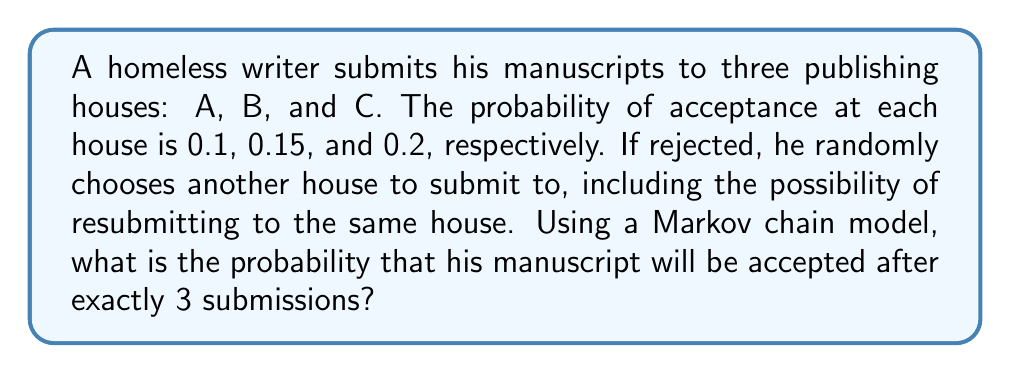Could you help me with this problem? Let's approach this step-by-step using a Markov chain model:

1) First, we need to define our states:
   - State A: Submitted to house A
   - State B: Submitted to house B
   - State C: Submitted to house C
   - State D: Accepted (absorbing state)

2) Now, let's create the transition matrix P:

   $$P = \begin{bmatrix}
   0.3 & 0.3 & 0.3 & 0.1 \\
   0.283̄ & 0.283̄ & 0.283̄ & 0.15 \\
   0.2666̄ & 0.2666̄ & 0.2666̄ & 0.2 \\
   0 & 0 & 0 & 1
   \end{bmatrix}$$

   Where the rows represent the current state and the columns represent the next state.

3) The probability of being accepted after exactly 3 submissions is the sum of the probabilities of:
   - Submitting to A twice, then getting accepted on the third try at A, B, or C
   - Submitting to B twice, then getting accepted on the third try at A, B, or C
   - Submitting to C twice, then getting accepted on the third try at A, B, or C

4) We can calculate this using matrix multiplication:

   $$\begin{bmatrix}
   \frac{1}{3} & \frac{1}{3} & \frac{1}{3} & 0
   \end{bmatrix} \cdot P^2 \cdot \begin{bmatrix}
   0.1 \\ 0.15 \\ 0.2 \\ 1
   \end{bmatrix}$$

5) Calculating $P^2$:

   $$P^2 = \begin{bmatrix}
   0.27 & 0.27 & 0.27 & 0.19 \\
   0.2633̄ & 0.2633̄ & 0.2633̄ & 0.21 \\
   0.2566̄ & 0.2566̄ & 0.2566̄ & 0.23 \\
   0 & 0 & 0 & 1
   \end{bmatrix}$$

6) Performing the final matrix multiplication:

   $$\frac{1}{3}(0.27 \cdot 0.1 + 0.27 \cdot 0.15 + 0.27 \cdot 0.2) +$$
   $$\frac{1}{3}(0.2633̄ \cdot 0.1 + 0.2633̄ \cdot 0.15 + 0.2633̄ \cdot 0.2) +$$
   $$\frac{1}{3}(0.2566̄ \cdot 0.1 + 0.2566̄ \cdot 0.15 + 0.2566̄ \cdot 0.2)$$

7) Simplifying:

   $$\frac{1}{3}(0.027 + 0.0405 + 0.054) +$$
   $$\frac{1}{3}(0.02633̄ + 0.0395 + 0.05266̄) +$$
   $$\frac{1}{3}(0.02566̄ + 0.0385 + 0.05133̄)$$

8) Final calculation:

   $$\frac{1}{3}(0.1215 + 0.1185 + 0.1155) = 0.1185$$
Answer: 0.1185 